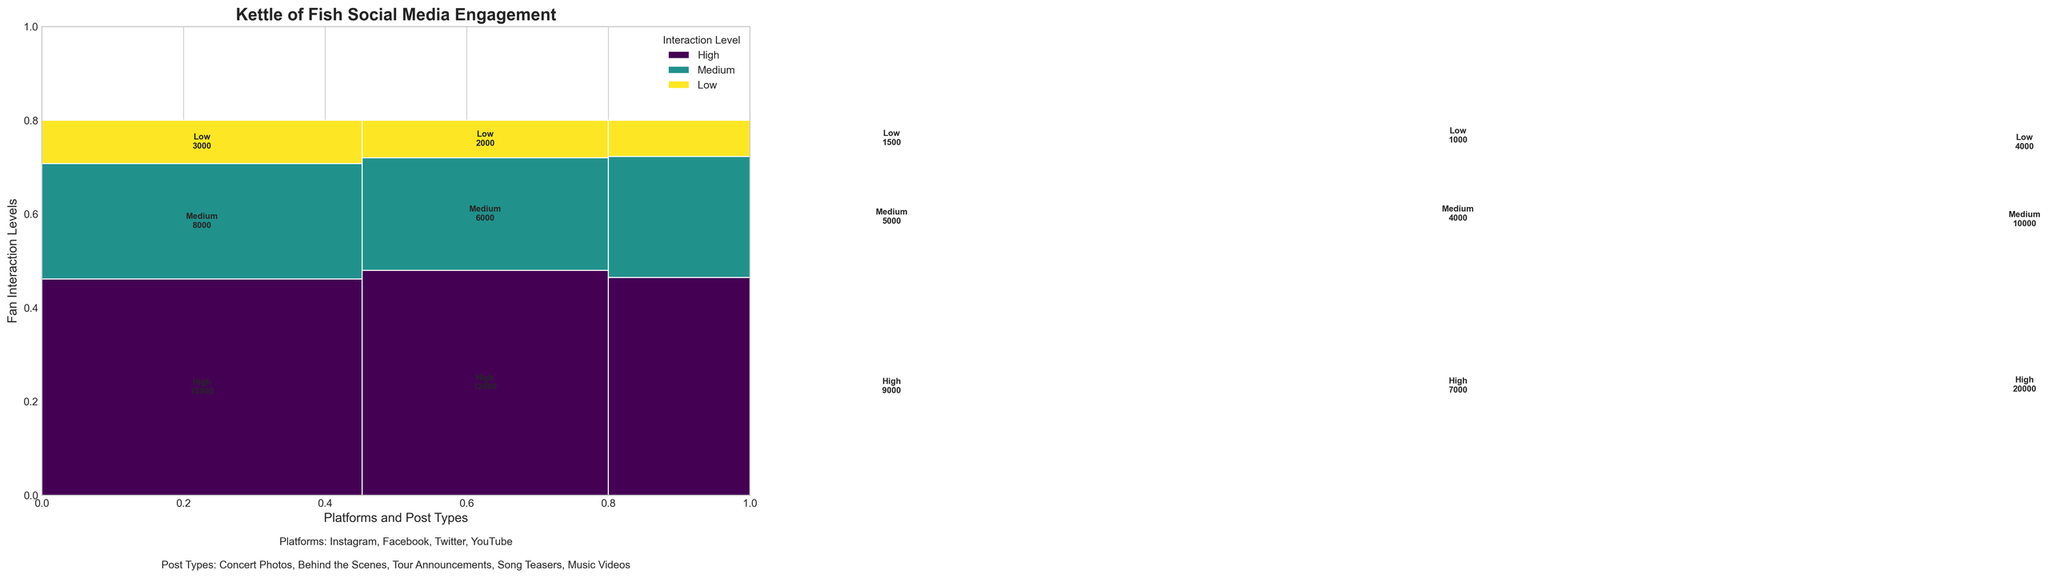What is the title of the figure? The title is typically found at the top of the figure. In this case, it's mentioned directly in the code.
Answer: Kettle of Fish Social Media Engagement How many different platforms are shown in the figure? The figure is segmented by different platforms, which are listed as Instagram, Facebook, Twitter, and YouTube in the code.
Answer: 4 Which platform has the highest total engagement count for "Behind the Scenes" posts? By looking at the segments, Instagram has 12,000 (High) + 6,000 (Medium) + 2,000 (Low) = 20,000 for "Behind the Scenes".
Answer: Instagram What is the engagement count difference between "Concert Photos" and "Behind the Scenes" posts on Instagram? For Instagram "Concert Photos", the total engagement is 15,000 (High) + 8,000 (Medium) + 3,000 (Low) = 26,000. For "Behind the Scenes", it's 20,000. The difference is 26,000 - 20,000 = 6,000.
Answer: 6,000 Which post type on YouTube has the highest engagement count and what is it? On YouTube, the only post type listed is "Music Videos" with counts of 20,000 (High) + 10,000 (Medium) + 4,000 (Low).
Answer: Music Videos, 20,000 Compare the engagement counts for "Tour Announcements" on Facebook to "Song Teasers" on Twitter. Which has more, and by how much? Adding the counts: Facebook "Tour Announcements" = 9,000 (High) + 5,000 (Medium) + 1,500 (Low) = 15,500. Twitter "Song Teasers" = 7,000 (High) + 4,000 (Medium) + 1,000 (Low) = 12,000. Facebook has more by 15,500 - 12,000 = 3,500.
Answer: Facebook by 3,500 Which interaction level (High, Medium, Low) appears most frequently across all platforms and post types? Counting the rectangles with respective counts indicated on them, "High" interaction levels appear the most frequently.
Answer: High What is the total engagement count for "Song Teasers" on Twitter? Summing up the counts for "Song Teasers" on Twitter: 7,000 (High) + 4,000 (Medium) + 1,000 (Low) = 12,000.
Answer: 12,000 Which interaction level is associated with the highest engagement count on YouTube? The "High" interaction level for "Music Videos" on YouTube shows the highest count of 20,000.
Answer: High What is the average engagement count across all interaction levels for "Tour Announcements" on Facebook? Sum total counts for "Tour Announcements" on Facebook (9,000 + 5,000 + 1,500 = 15,500) and divide by 3 = 15,500 / 3 ≈ 5,167.
Answer: 5,167 